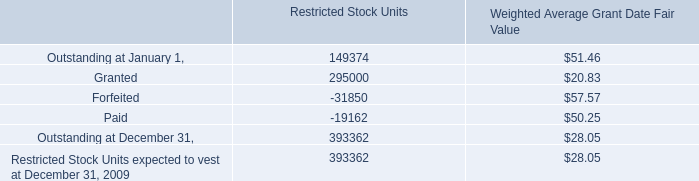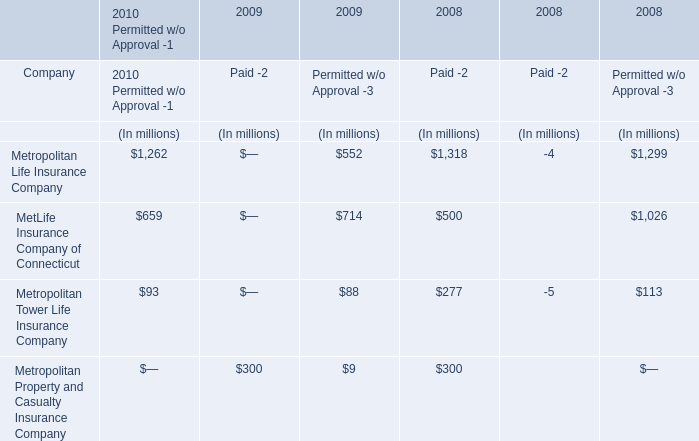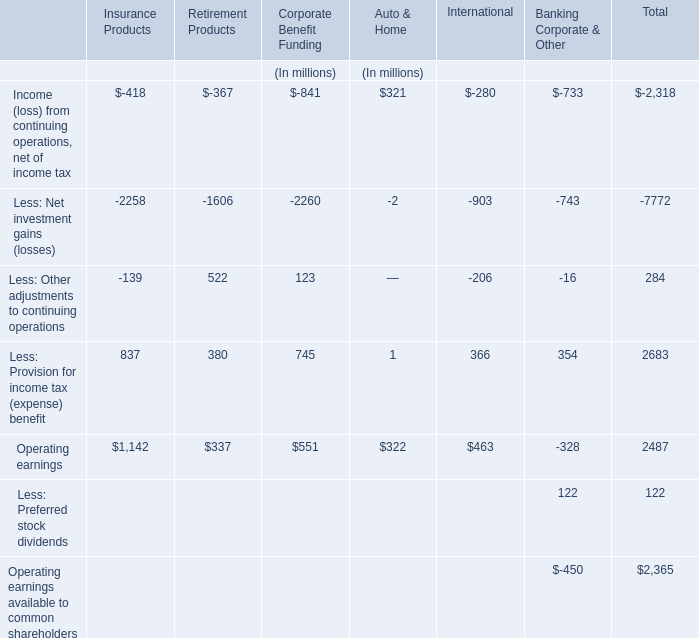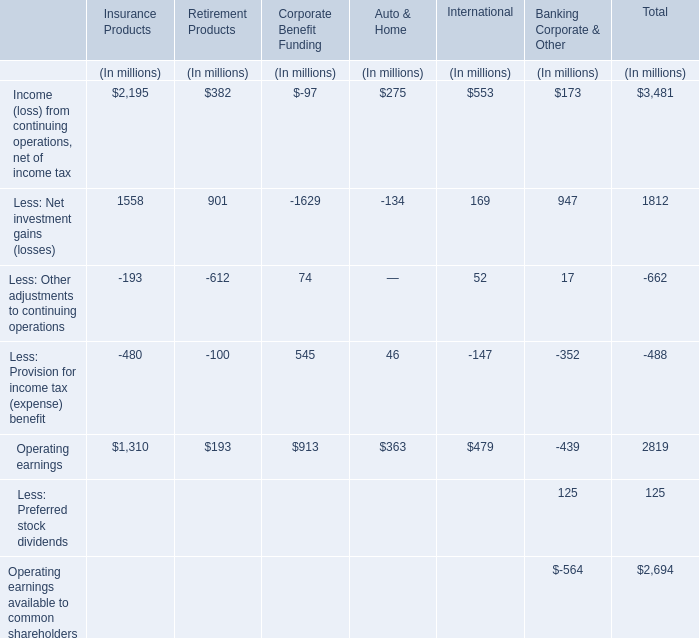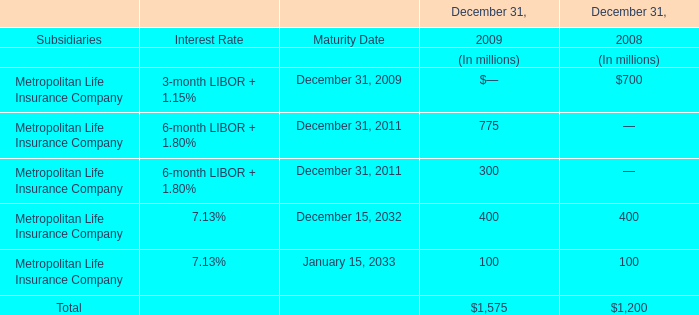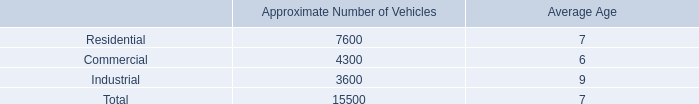In the section with largest amount of Less: Other adjustments to continuing operations, what's the sum of Corporate Benefit Funding? (in million) 
Computations: ((((-97 - 1629) + 74) + 545) + 913)
Answer: -194.0. 